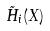Convert formula to latex. <formula><loc_0><loc_0><loc_500><loc_500>\tilde { H } _ { i } ( X )</formula> 